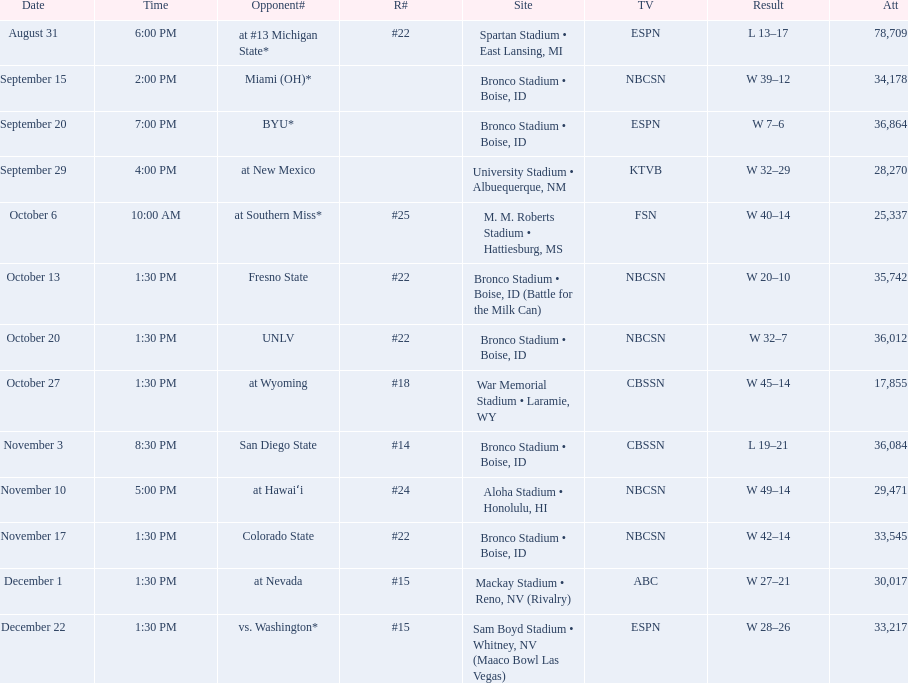Would you mind parsing the complete table? {'header': ['Date', 'Time', 'Opponent#', 'R#', 'Site', 'TV', 'Result', 'Att'], 'rows': [['August 31', '6:00 PM', 'at\xa0#13\xa0Michigan State*', '#22', 'Spartan Stadium • East Lansing, MI', 'ESPN', 'L\xa013–17', '78,709'], ['September 15', '2:00 PM', 'Miami (OH)*', '', 'Bronco Stadium • Boise, ID', 'NBCSN', 'W\xa039–12', '34,178'], ['September 20', '7:00 PM', 'BYU*', '', 'Bronco Stadium • Boise, ID', 'ESPN', 'W\xa07–6', '36,864'], ['September 29', '4:00 PM', 'at\xa0New Mexico', '', 'University Stadium • Albuequerque, NM', 'KTVB', 'W\xa032–29', '28,270'], ['October 6', '10:00 AM', 'at\xa0Southern Miss*', '#25', 'M. M. Roberts Stadium • Hattiesburg, MS', 'FSN', 'W\xa040–14', '25,337'], ['October 13', '1:30 PM', 'Fresno State', '#22', 'Bronco Stadium • Boise, ID (Battle for the Milk Can)', 'NBCSN', 'W\xa020–10', '35,742'], ['October 20', '1:30 PM', 'UNLV', '#22', 'Bronco Stadium • Boise, ID', 'NBCSN', 'W\xa032–7', '36,012'], ['October 27', '1:30 PM', 'at\xa0Wyoming', '#18', 'War Memorial Stadium • Laramie, WY', 'CBSSN', 'W\xa045–14', '17,855'], ['November 3', '8:30 PM', 'San Diego State', '#14', 'Bronco Stadium • Boise, ID', 'CBSSN', 'L\xa019–21', '36,084'], ['November 10', '5:00 PM', 'at\xa0Hawaiʻi', '#24', 'Aloha Stadium • Honolulu, HI', 'NBCSN', 'W\xa049–14', '29,471'], ['November 17', '1:30 PM', 'Colorado State', '#22', 'Bronco Stadium • Boise, ID', 'NBCSN', 'W\xa042–14', '33,545'], ['December 1', '1:30 PM', 'at\xa0Nevada', '#15', 'Mackay Stadium • Reno, NV (Rivalry)', 'ABC', 'W\xa027–21', '30,017'], ['December 22', '1:30 PM', 'vs.\xa0Washington*', '#15', 'Sam Boyd Stadium • Whitney, NV (Maaco Bowl Las Vegas)', 'ESPN', 'W\xa028–26', '33,217']]} What rank was boise state after november 10th? #22. 